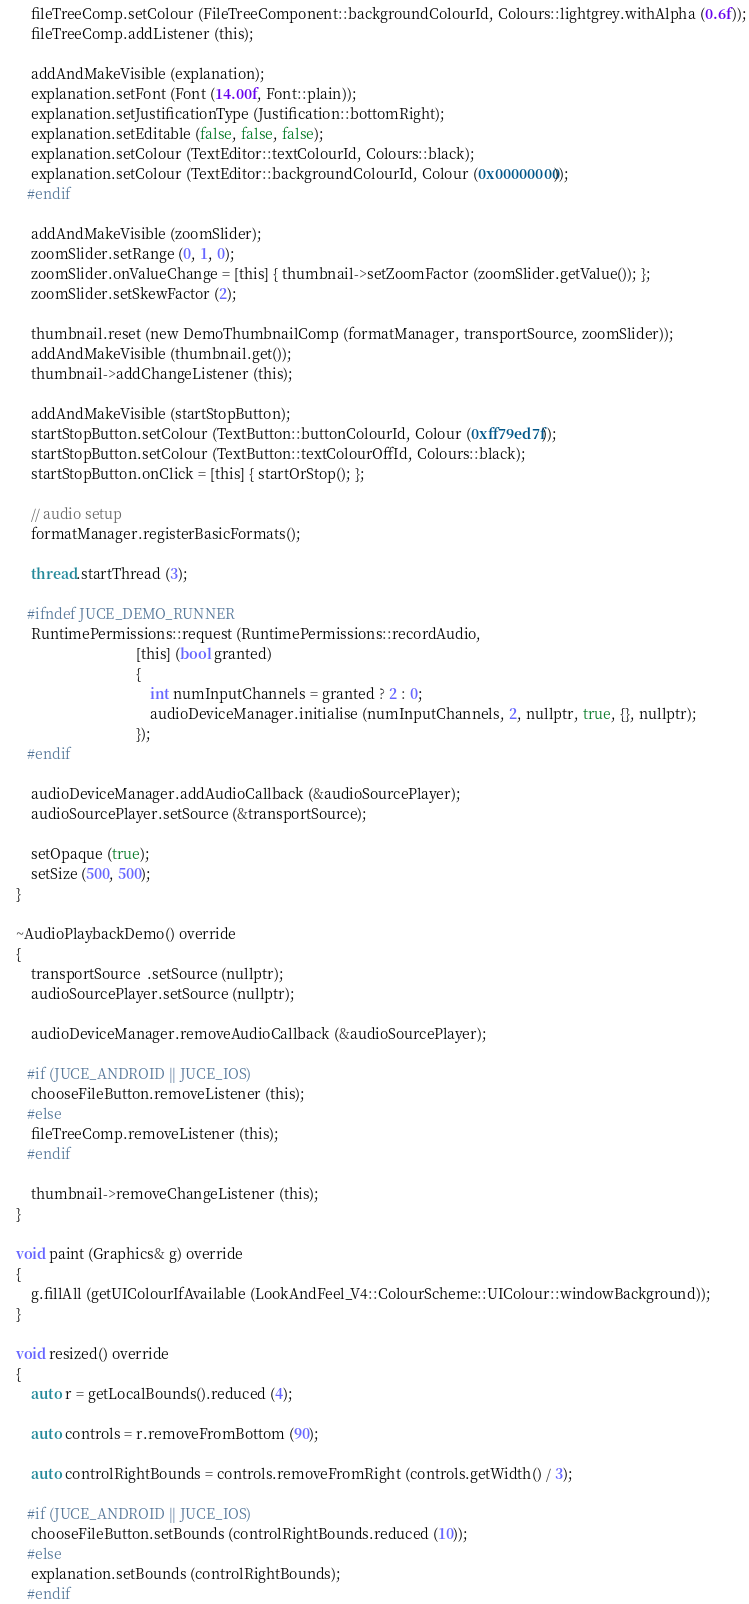Convert code to text. <code><loc_0><loc_0><loc_500><loc_500><_C_>        fileTreeComp.setColour (FileTreeComponent::backgroundColourId, Colours::lightgrey.withAlpha (0.6f));
        fileTreeComp.addListener (this);

        addAndMakeVisible (explanation);
        explanation.setFont (Font (14.00f, Font::plain));
        explanation.setJustificationType (Justification::bottomRight);
        explanation.setEditable (false, false, false);
        explanation.setColour (TextEditor::textColourId, Colours::black);
        explanation.setColour (TextEditor::backgroundColourId, Colour (0x00000000));
       #endif

        addAndMakeVisible (zoomSlider);
        zoomSlider.setRange (0, 1, 0);
        zoomSlider.onValueChange = [this] { thumbnail->setZoomFactor (zoomSlider.getValue()); };
        zoomSlider.setSkewFactor (2);

        thumbnail.reset (new DemoThumbnailComp (formatManager, transportSource, zoomSlider));
        addAndMakeVisible (thumbnail.get());
        thumbnail->addChangeListener (this);

        addAndMakeVisible (startStopButton);
        startStopButton.setColour (TextButton::buttonColourId, Colour (0xff79ed7f));
        startStopButton.setColour (TextButton::textColourOffId, Colours::black);
        startStopButton.onClick = [this] { startOrStop(); };

        // audio setup
        formatManager.registerBasicFormats();

        thread.startThread (3);

       #ifndef JUCE_DEMO_RUNNER
        RuntimePermissions::request (RuntimePermissions::recordAudio,
                                     [this] (bool granted)
                                     {
                                         int numInputChannels = granted ? 2 : 0;
                                         audioDeviceManager.initialise (numInputChannels, 2, nullptr, true, {}, nullptr);
                                     });
       #endif

        audioDeviceManager.addAudioCallback (&audioSourcePlayer);
        audioSourcePlayer.setSource (&transportSource);

        setOpaque (true);
        setSize (500, 500);
    }

    ~AudioPlaybackDemo() override
    {
        transportSource  .setSource (nullptr);
        audioSourcePlayer.setSource (nullptr);

        audioDeviceManager.removeAudioCallback (&audioSourcePlayer);

       #if (JUCE_ANDROID || JUCE_IOS)
        chooseFileButton.removeListener (this);
       #else
        fileTreeComp.removeListener (this);
       #endif

        thumbnail->removeChangeListener (this);
    }

    void paint (Graphics& g) override
    {
        g.fillAll (getUIColourIfAvailable (LookAndFeel_V4::ColourScheme::UIColour::windowBackground));
    }

    void resized() override
    {
        auto r = getLocalBounds().reduced (4);

        auto controls = r.removeFromBottom (90);

        auto controlRightBounds = controls.removeFromRight (controls.getWidth() / 3);

       #if (JUCE_ANDROID || JUCE_IOS)
        chooseFileButton.setBounds (controlRightBounds.reduced (10));
       #else
        explanation.setBounds (controlRightBounds);
       #endif
</code> 